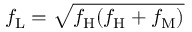Convert formula to latex. <formula><loc_0><loc_0><loc_500><loc_500>f _ { L } = \sqrt { f _ { H } ( f _ { H } + f _ { M } ) }</formula> 